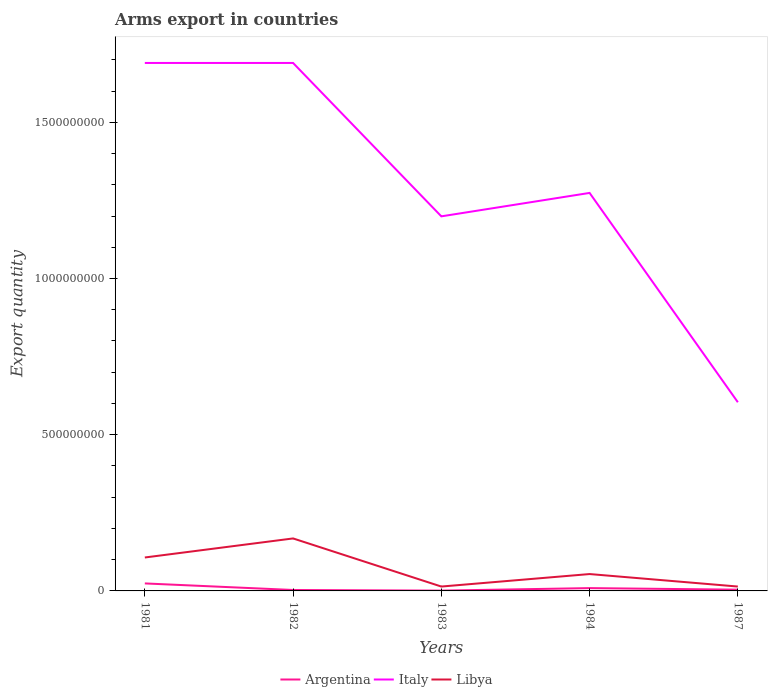Does the line corresponding to Libya intersect with the line corresponding to Italy?
Ensure brevity in your answer.  No. Is the number of lines equal to the number of legend labels?
Provide a succinct answer. Yes. Across all years, what is the maximum total arms export in Italy?
Your response must be concise. 6.04e+08. In which year was the total arms export in Libya maximum?
Offer a very short reply. 1983. What is the total total arms export in Italy in the graph?
Make the answer very short. 5.95e+08. What is the difference between the highest and the second highest total arms export in Libya?
Offer a very short reply. 1.54e+08. What is the difference between the highest and the lowest total arms export in Argentina?
Give a very brief answer. 2. Is the total arms export in Italy strictly greater than the total arms export in Argentina over the years?
Offer a very short reply. No. How many lines are there?
Offer a terse response. 3. What is the difference between two consecutive major ticks on the Y-axis?
Offer a terse response. 5.00e+08. Where does the legend appear in the graph?
Provide a short and direct response. Bottom center. How many legend labels are there?
Provide a succinct answer. 3. How are the legend labels stacked?
Give a very brief answer. Horizontal. What is the title of the graph?
Give a very brief answer. Arms export in countries. Does "Colombia" appear as one of the legend labels in the graph?
Offer a very short reply. No. What is the label or title of the Y-axis?
Offer a very short reply. Export quantity. What is the Export quantity in Argentina in 1981?
Your response must be concise. 2.40e+07. What is the Export quantity of Italy in 1981?
Provide a short and direct response. 1.69e+09. What is the Export quantity in Libya in 1981?
Your answer should be compact. 1.07e+08. What is the Export quantity of Italy in 1982?
Ensure brevity in your answer.  1.69e+09. What is the Export quantity of Libya in 1982?
Your answer should be very brief. 1.68e+08. What is the Export quantity of Italy in 1983?
Provide a short and direct response. 1.20e+09. What is the Export quantity of Libya in 1983?
Offer a very short reply. 1.40e+07. What is the Export quantity of Argentina in 1984?
Your answer should be compact. 9.00e+06. What is the Export quantity of Italy in 1984?
Keep it short and to the point. 1.27e+09. What is the Export quantity in Libya in 1984?
Offer a terse response. 5.40e+07. What is the Export quantity in Italy in 1987?
Give a very brief answer. 6.04e+08. What is the Export quantity in Libya in 1987?
Your response must be concise. 1.40e+07. Across all years, what is the maximum Export quantity of Argentina?
Your answer should be very brief. 2.40e+07. Across all years, what is the maximum Export quantity of Italy?
Provide a short and direct response. 1.69e+09. Across all years, what is the maximum Export quantity of Libya?
Make the answer very short. 1.68e+08. Across all years, what is the minimum Export quantity in Argentina?
Ensure brevity in your answer.  1.00e+06. Across all years, what is the minimum Export quantity of Italy?
Your answer should be very brief. 6.04e+08. Across all years, what is the minimum Export quantity in Libya?
Offer a terse response. 1.40e+07. What is the total Export quantity of Argentina in the graph?
Make the answer very short. 4.10e+07. What is the total Export quantity of Italy in the graph?
Ensure brevity in your answer.  6.46e+09. What is the total Export quantity in Libya in the graph?
Provide a short and direct response. 3.57e+08. What is the difference between the Export quantity of Argentina in 1981 and that in 1982?
Keep it short and to the point. 2.10e+07. What is the difference between the Export quantity of Libya in 1981 and that in 1982?
Ensure brevity in your answer.  -6.10e+07. What is the difference between the Export quantity of Argentina in 1981 and that in 1983?
Offer a very short reply. 2.30e+07. What is the difference between the Export quantity in Italy in 1981 and that in 1983?
Provide a succinct answer. 4.91e+08. What is the difference between the Export quantity in Libya in 1981 and that in 1983?
Make the answer very short. 9.30e+07. What is the difference between the Export quantity of Argentina in 1981 and that in 1984?
Give a very brief answer. 1.50e+07. What is the difference between the Export quantity of Italy in 1981 and that in 1984?
Your answer should be very brief. 4.16e+08. What is the difference between the Export quantity of Libya in 1981 and that in 1984?
Offer a terse response. 5.30e+07. What is the difference between the Export quantity of Italy in 1981 and that in 1987?
Provide a succinct answer. 1.09e+09. What is the difference between the Export quantity of Libya in 1981 and that in 1987?
Your response must be concise. 9.30e+07. What is the difference between the Export quantity of Italy in 1982 and that in 1983?
Your answer should be compact. 4.91e+08. What is the difference between the Export quantity of Libya in 1982 and that in 1983?
Provide a succinct answer. 1.54e+08. What is the difference between the Export quantity of Argentina in 1982 and that in 1984?
Your answer should be very brief. -6.00e+06. What is the difference between the Export quantity of Italy in 1982 and that in 1984?
Give a very brief answer. 4.16e+08. What is the difference between the Export quantity in Libya in 1982 and that in 1984?
Offer a terse response. 1.14e+08. What is the difference between the Export quantity of Argentina in 1982 and that in 1987?
Provide a succinct answer. -1.00e+06. What is the difference between the Export quantity in Italy in 1982 and that in 1987?
Ensure brevity in your answer.  1.09e+09. What is the difference between the Export quantity of Libya in 1982 and that in 1987?
Your answer should be compact. 1.54e+08. What is the difference between the Export quantity in Argentina in 1983 and that in 1984?
Give a very brief answer. -8.00e+06. What is the difference between the Export quantity in Italy in 1983 and that in 1984?
Your answer should be compact. -7.50e+07. What is the difference between the Export quantity in Libya in 1983 and that in 1984?
Keep it short and to the point. -4.00e+07. What is the difference between the Export quantity of Italy in 1983 and that in 1987?
Your response must be concise. 5.95e+08. What is the difference between the Export quantity in Argentina in 1984 and that in 1987?
Give a very brief answer. 5.00e+06. What is the difference between the Export quantity of Italy in 1984 and that in 1987?
Provide a succinct answer. 6.70e+08. What is the difference between the Export quantity of Libya in 1984 and that in 1987?
Make the answer very short. 4.00e+07. What is the difference between the Export quantity in Argentina in 1981 and the Export quantity in Italy in 1982?
Provide a short and direct response. -1.67e+09. What is the difference between the Export quantity of Argentina in 1981 and the Export quantity of Libya in 1982?
Your answer should be compact. -1.44e+08. What is the difference between the Export quantity of Italy in 1981 and the Export quantity of Libya in 1982?
Provide a succinct answer. 1.52e+09. What is the difference between the Export quantity in Argentina in 1981 and the Export quantity in Italy in 1983?
Offer a terse response. -1.18e+09. What is the difference between the Export quantity in Argentina in 1981 and the Export quantity in Libya in 1983?
Make the answer very short. 1.00e+07. What is the difference between the Export quantity in Italy in 1981 and the Export quantity in Libya in 1983?
Keep it short and to the point. 1.68e+09. What is the difference between the Export quantity in Argentina in 1981 and the Export quantity in Italy in 1984?
Keep it short and to the point. -1.25e+09. What is the difference between the Export quantity in Argentina in 1981 and the Export quantity in Libya in 1984?
Provide a short and direct response. -3.00e+07. What is the difference between the Export quantity of Italy in 1981 and the Export quantity of Libya in 1984?
Provide a short and direct response. 1.64e+09. What is the difference between the Export quantity in Argentina in 1981 and the Export quantity in Italy in 1987?
Your response must be concise. -5.80e+08. What is the difference between the Export quantity of Italy in 1981 and the Export quantity of Libya in 1987?
Your answer should be very brief. 1.68e+09. What is the difference between the Export quantity of Argentina in 1982 and the Export quantity of Italy in 1983?
Your answer should be very brief. -1.20e+09. What is the difference between the Export quantity in Argentina in 1982 and the Export quantity in Libya in 1983?
Ensure brevity in your answer.  -1.10e+07. What is the difference between the Export quantity in Italy in 1982 and the Export quantity in Libya in 1983?
Keep it short and to the point. 1.68e+09. What is the difference between the Export quantity of Argentina in 1982 and the Export quantity of Italy in 1984?
Your response must be concise. -1.27e+09. What is the difference between the Export quantity of Argentina in 1982 and the Export quantity of Libya in 1984?
Offer a very short reply. -5.10e+07. What is the difference between the Export quantity in Italy in 1982 and the Export quantity in Libya in 1984?
Provide a short and direct response. 1.64e+09. What is the difference between the Export quantity of Argentina in 1982 and the Export quantity of Italy in 1987?
Provide a succinct answer. -6.01e+08. What is the difference between the Export quantity of Argentina in 1982 and the Export quantity of Libya in 1987?
Your answer should be compact. -1.10e+07. What is the difference between the Export quantity in Italy in 1982 and the Export quantity in Libya in 1987?
Make the answer very short. 1.68e+09. What is the difference between the Export quantity in Argentina in 1983 and the Export quantity in Italy in 1984?
Provide a short and direct response. -1.27e+09. What is the difference between the Export quantity of Argentina in 1983 and the Export quantity of Libya in 1984?
Ensure brevity in your answer.  -5.30e+07. What is the difference between the Export quantity in Italy in 1983 and the Export quantity in Libya in 1984?
Provide a short and direct response. 1.14e+09. What is the difference between the Export quantity in Argentina in 1983 and the Export quantity in Italy in 1987?
Keep it short and to the point. -6.03e+08. What is the difference between the Export quantity of Argentina in 1983 and the Export quantity of Libya in 1987?
Your response must be concise. -1.30e+07. What is the difference between the Export quantity of Italy in 1983 and the Export quantity of Libya in 1987?
Offer a very short reply. 1.18e+09. What is the difference between the Export quantity of Argentina in 1984 and the Export quantity of Italy in 1987?
Offer a terse response. -5.95e+08. What is the difference between the Export quantity in Argentina in 1984 and the Export quantity in Libya in 1987?
Provide a short and direct response. -5.00e+06. What is the difference between the Export quantity of Italy in 1984 and the Export quantity of Libya in 1987?
Your response must be concise. 1.26e+09. What is the average Export quantity in Argentina per year?
Your response must be concise. 8.20e+06. What is the average Export quantity of Italy per year?
Provide a short and direct response. 1.29e+09. What is the average Export quantity in Libya per year?
Offer a terse response. 7.14e+07. In the year 1981, what is the difference between the Export quantity of Argentina and Export quantity of Italy?
Provide a succinct answer. -1.67e+09. In the year 1981, what is the difference between the Export quantity in Argentina and Export quantity in Libya?
Give a very brief answer. -8.30e+07. In the year 1981, what is the difference between the Export quantity of Italy and Export quantity of Libya?
Ensure brevity in your answer.  1.58e+09. In the year 1982, what is the difference between the Export quantity of Argentina and Export quantity of Italy?
Make the answer very short. -1.69e+09. In the year 1982, what is the difference between the Export quantity in Argentina and Export quantity in Libya?
Provide a short and direct response. -1.65e+08. In the year 1982, what is the difference between the Export quantity in Italy and Export quantity in Libya?
Offer a terse response. 1.52e+09. In the year 1983, what is the difference between the Export quantity of Argentina and Export quantity of Italy?
Give a very brief answer. -1.20e+09. In the year 1983, what is the difference between the Export quantity of Argentina and Export quantity of Libya?
Make the answer very short. -1.30e+07. In the year 1983, what is the difference between the Export quantity in Italy and Export quantity in Libya?
Offer a very short reply. 1.18e+09. In the year 1984, what is the difference between the Export quantity in Argentina and Export quantity in Italy?
Give a very brief answer. -1.26e+09. In the year 1984, what is the difference between the Export quantity of Argentina and Export quantity of Libya?
Make the answer very short. -4.50e+07. In the year 1984, what is the difference between the Export quantity in Italy and Export quantity in Libya?
Keep it short and to the point. 1.22e+09. In the year 1987, what is the difference between the Export quantity in Argentina and Export quantity in Italy?
Provide a succinct answer. -6.00e+08. In the year 1987, what is the difference between the Export quantity in Argentina and Export quantity in Libya?
Provide a succinct answer. -1.00e+07. In the year 1987, what is the difference between the Export quantity in Italy and Export quantity in Libya?
Offer a terse response. 5.90e+08. What is the ratio of the Export quantity of Argentina in 1981 to that in 1982?
Provide a succinct answer. 8. What is the ratio of the Export quantity in Libya in 1981 to that in 1982?
Your answer should be very brief. 0.64. What is the ratio of the Export quantity in Argentina in 1981 to that in 1983?
Offer a terse response. 24. What is the ratio of the Export quantity in Italy in 1981 to that in 1983?
Your answer should be compact. 1.41. What is the ratio of the Export quantity in Libya in 1981 to that in 1983?
Ensure brevity in your answer.  7.64. What is the ratio of the Export quantity in Argentina in 1981 to that in 1984?
Provide a succinct answer. 2.67. What is the ratio of the Export quantity of Italy in 1981 to that in 1984?
Make the answer very short. 1.33. What is the ratio of the Export quantity of Libya in 1981 to that in 1984?
Make the answer very short. 1.98. What is the ratio of the Export quantity of Argentina in 1981 to that in 1987?
Your answer should be compact. 6. What is the ratio of the Export quantity in Italy in 1981 to that in 1987?
Your response must be concise. 2.8. What is the ratio of the Export quantity of Libya in 1981 to that in 1987?
Make the answer very short. 7.64. What is the ratio of the Export quantity of Argentina in 1982 to that in 1983?
Offer a terse response. 3. What is the ratio of the Export quantity in Italy in 1982 to that in 1983?
Provide a succinct answer. 1.41. What is the ratio of the Export quantity in Libya in 1982 to that in 1983?
Make the answer very short. 12. What is the ratio of the Export quantity in Italy in 1982 to that in 1984?
Offer a terse response. 1.33. What is the ratio of the Export quantity in Libya in 1982 to that in 1984?
Keep it short and to the point. 3.11. What is the ratio of the Export quantity in Argentina in 1982 to that in 1987?
Give a very brief answer. 0.75. What is the ratio of the Export quantity in Italy in 1982 to that in 1987?
Offer a terse response. 2.8. What is the ratio of the Export quantity in Libya in 1982 to that in 1987?
Give a very brief answer. 12. What is the ratio of the Export quantity in Argentina in 1983 to that in 1984?
Your response must be concise. 0.11. What is the ratio of the Export quantity in Italy in 1983 to that in 1984?
Ensure brevity in your answer.  0.94. What is the ratio of the Export quantity in Libya in 1983 to that in 1984?
Offer a terse response. 0.26. What is the ratio of the Export quantity in Argentina in 1983 to that in 1987?
Keep it short and to the point. 0.25. What is the ratio of the Export quantity in Italy in 1983 to that in 1987?
Provide a succinct answer. 1.99. What is the ratio of the Export quantity of Argentina in 1984 to that in 1987?
Offer a very short reply. 2.25. What is the ratio of the Export quantity of Italy in 1984 to that in 1987?
Offer a terse response. 2.11. What is the ratio of the Export quantity in Libya in 1984 to that in 1987?
Offer a terse response. 3.86. What is the difference between the highest and the second highest Export quantity of Argentina?
Offer a terse response. 1.50e+07. What is the difference between the highest and the second highest Export quantity in Libya?
Your response must be concise. 6.10e+07. What is the difference between the highest and the lowest Export quantity of Argentina?
Give a very brief answer. 2.30e+07. What is the difference between the highest and the lowest Export quantity in Italy?
Provide a short and direct response. 1.09e+09. What is the difference between the highest and the lowest Export quantity of Libya?
Keep it short and to the point. 1.54e+08. 